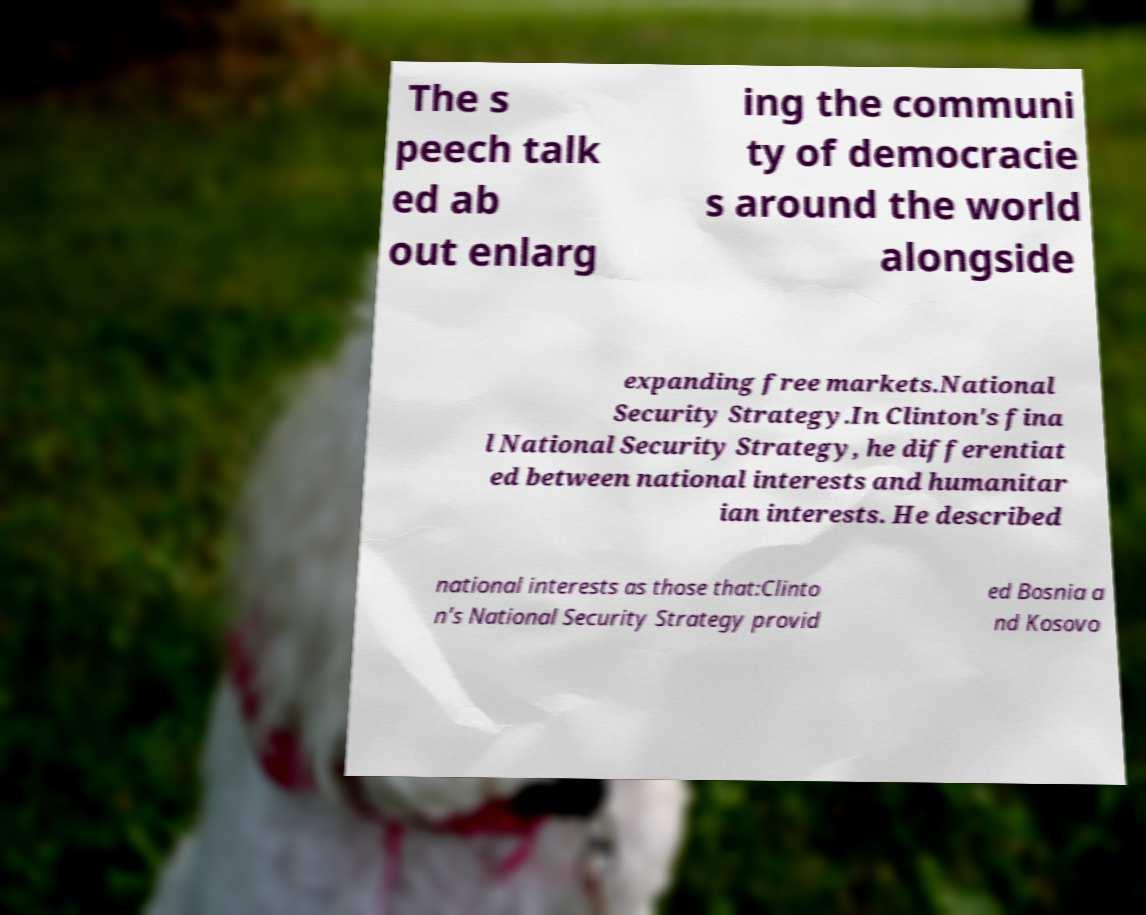Please read and relay the text visible in this image. What does it say? The s peech talk ed ab out enlarg ing the communi ty of democracie s around the world alongside expanding free markets.National Security Strategy.In Clinton's fina l National Security Strategy, he differentiat ed between national interests and humanitar ian interests. He described national interests as those that:Clinto n's National Security Strategy provid ed Bosnia a nd Kosovo 